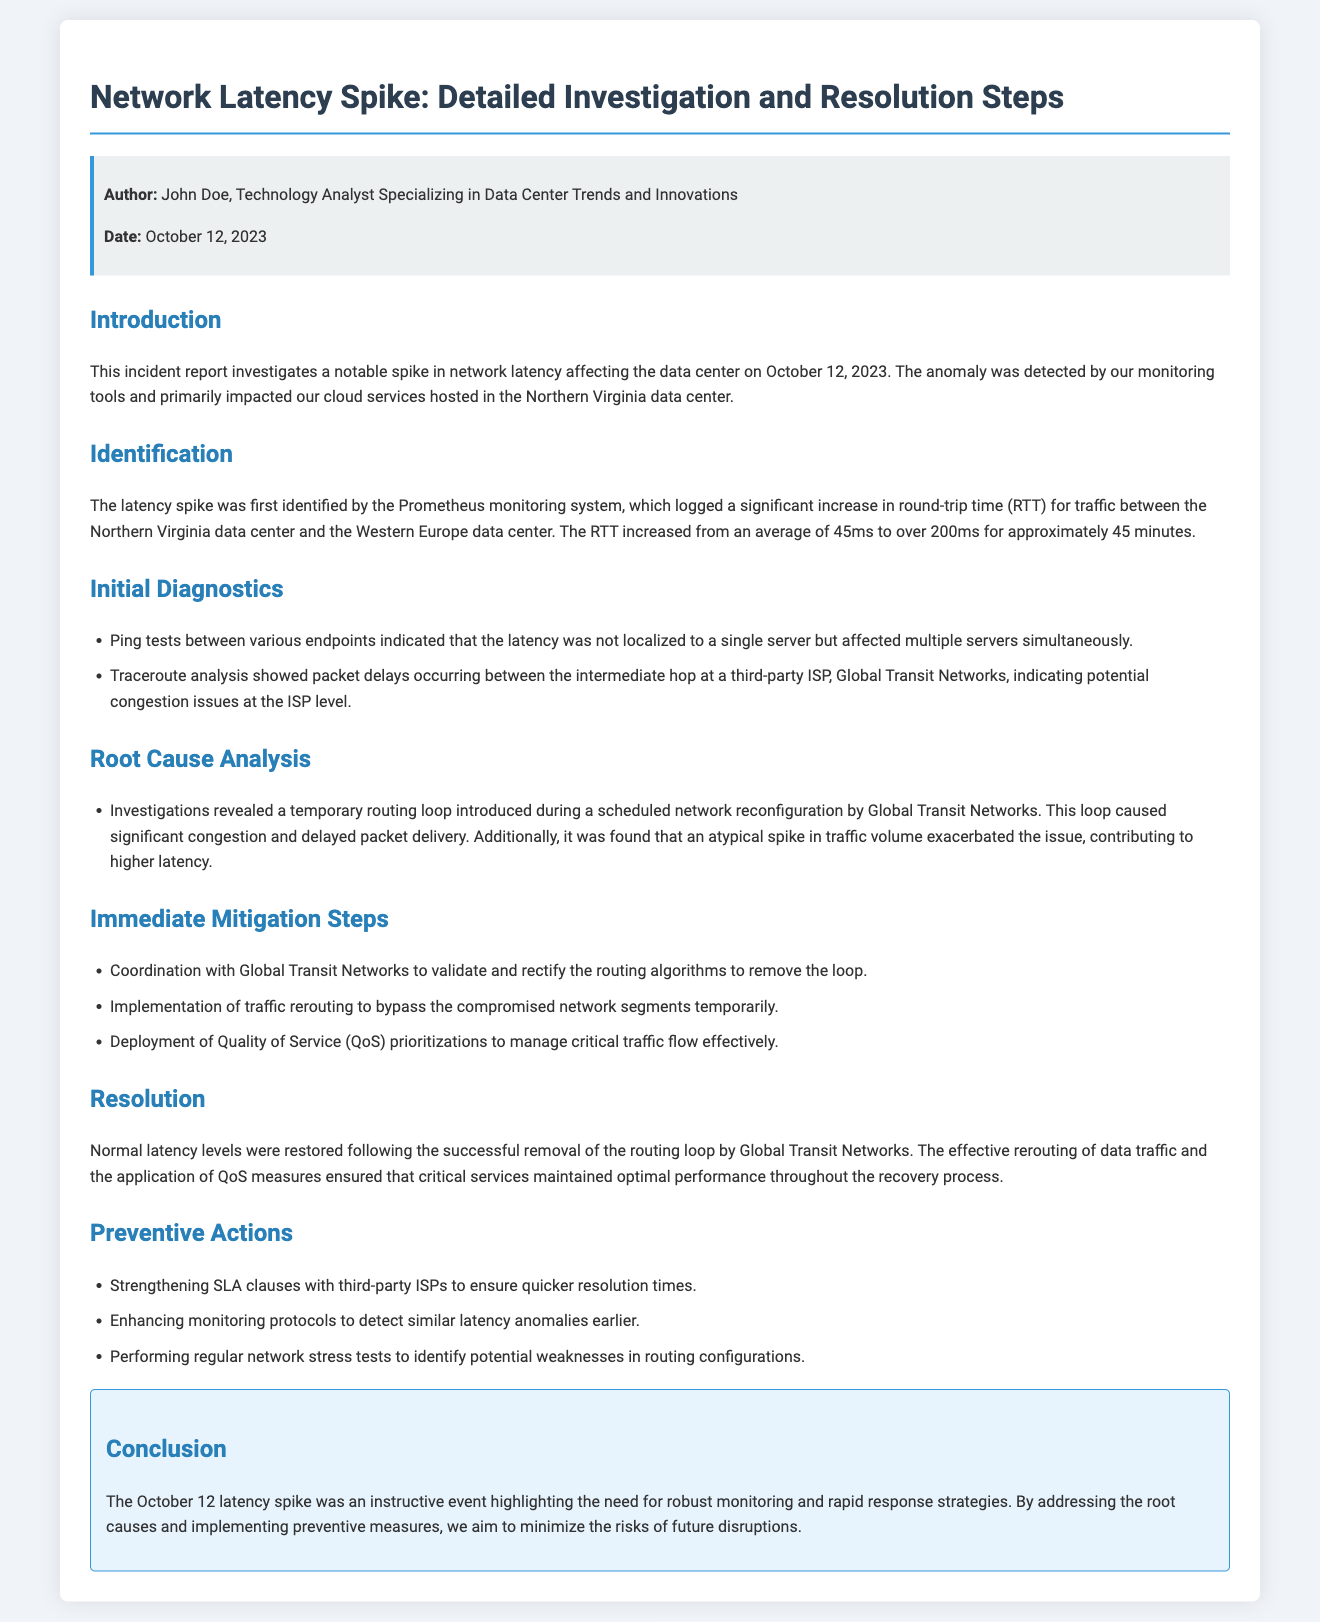What date was the latency spike identified? The report states that the latency spike was identified on October 12, 2023.
Answer: October 12, 2023 Who authored the incident report? The incident report identifies John Doe as the author.
Answer: John Doe What was the average round-trip time before the spike? The document mentions that the average round-trip time increased from 45ms, indicating that this was the RTT before the spike.
Answer: 45ms What third-party ISP was involved in the incident? The report indicates that Global Transit Networks was the ISP involved in the situation.
Answer: Global Transit Networks What immediate action was taken regarding the routing algorithm? The report states that coordination with Global Transit Networks was undertaken to validate and rectify the routing algorithms.
Answer: Validate and rectify What led to the latency spike according to the root cause analysis? The root cause analysis revealed that a routing loop and an atypical spike in traffic volume caused the latency spike.
Answer: Routing loop and traffic spike How long did the latency increase last? The report specifies that the latency increase lasted for approximately 45 minutes.
Answer: Approximately 45 minutes What is one preventive action mentioned in the report? The document lists strengthening SLA clauses with third-party ISPs as a preventive action.
Answer: Strengthening SLA clauses What did the rerouting of data traffic aim to achieve? The report indicates that the rerouting aimed to bypass the compromised network segments temporarily.
Answer: Bypass compromised network segments 